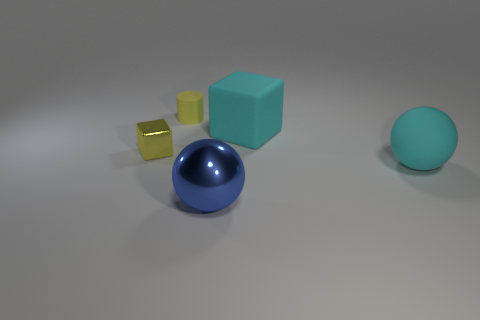How many other things are the same material as the tiny yellow block?
Ensure brevity in your answer.  1. What color is the large thing that is the same shape as the small yellow shiny object?
Keep it short and to the point. Cyan. What is the color of the small thing that is the same material as the big blue thing?
Keep it short and to the point. Yellow. There is a object that is to the right of the tiny yellow metallic object and to the left of the large blue metallic thing; what size is it?
Your response must be concise. Small. Is the number of blue metallic spheres behind the small metal thing less than the number of large objects in front of the small yellow rubber cylinder?
Provide a succinct answer. Yes. Is the material of the block that is to the right of the tiny rubber cylinder the same as the block that is left of the large block?
Offer a very short reply. No. There is a cube that is the same color as the cylinder; what is it made of?
Provide a succinct answer. Metal. There is a object that is behind the yellow block and in front of the rubber cylinder; what shape is it?
Offer a terse response. Cube. What is the material of the object to the left of the yellow thing to the right of the small yellow cube?
Keep it short and to the point. Metal. Are there more small blue metallic balls than cyan matte objects?
Your answer should be compact. No. 